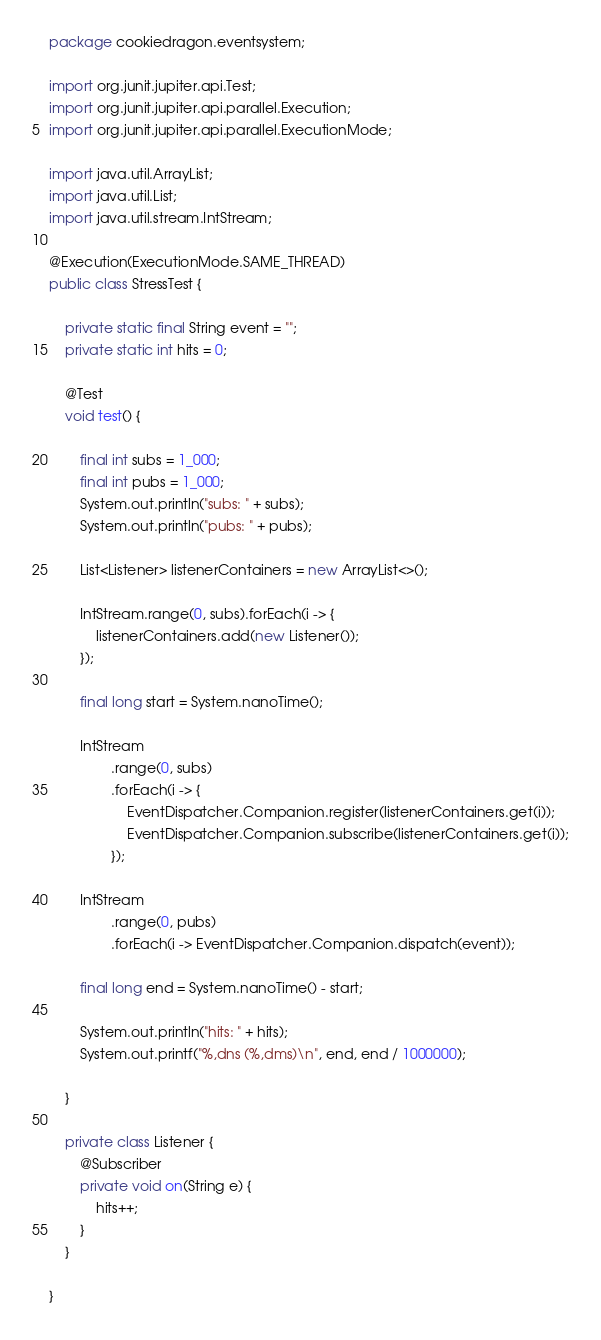<code> <loc_0><loc_0><loc_500><loc_500><_Java_>package cookiedragon.eventsystem;

import org.junit.jupiter.api.Test;
import org.junit.jupiter.api.parallel.Execution;
import org.junit.jupiter.api.parallel.ExecutionMode;

import java.util.ArrayList;
import java.util.List;
import java.util.stream.IntStream;

@Execution(ExecutionMode.SAME_THREAD)
public class StressTest {

    private static final String event = "";
    private static int hits = 0;

    @Test
    void test() {

        final int subs = 1_000;
        final int pubs = 1_000;
        System.out.println("subs: " + subs);
        System.out.println("pubs: " + pubs);

        List<Listener> listenerContainers = new ArrayList<>();

        IntStream.range(0, subs).forEach(i -> {
            listenerContainers.add(new Listener());
        });

        final long start = System.nanoTime();

        IntStream
                .range(0, subs)
                .forEach(i -> {
                    EventDispatcher.Companion.register(listenerContainers.get(i));
                    EventDispatcher.Companion.subscribe(listenerContainers.get(i));
                });

        IntStream
                .range(0, pubs)
                .forEach(i -> EventDispatcher.Companion.dispatch(event));

        final long end = System.nanoTime() - start;

        System.out.println("hits: " + hits);
        System.out.printf("%,dns (%,dms)\n", end, end / 1000000);

    }

    private class Listener {
        @Subscriber
        private void on(String e) {
            hits++;
        }
    }

}
</code> 